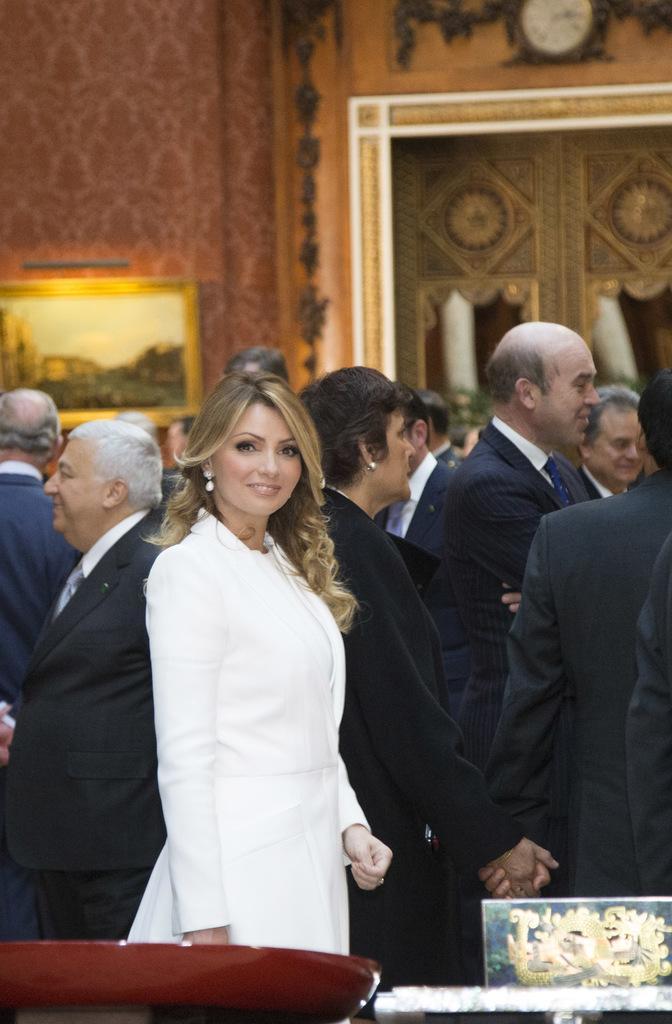Could you give a brief overview of what you see in this image? In this image we can see men and women standing on the floor. In the background there are wall hangings to the wall and a clock. 